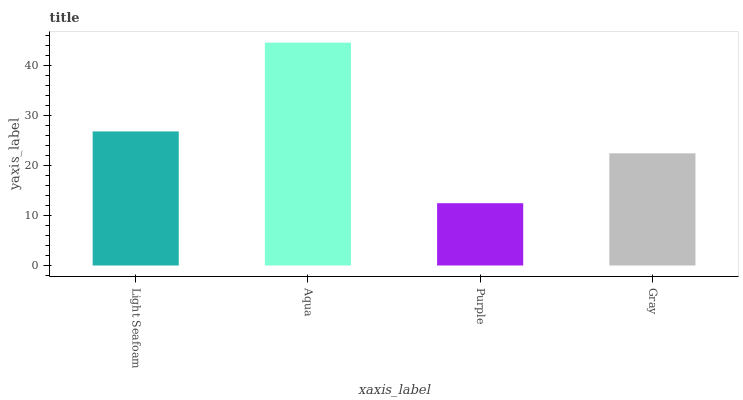Is Purple the minimum?
Answer yes or no. Yes. Is Aqua the maximum?
Answer yes or no. Yes. Is Aqua the minimum?
Answer yes or no. No. Is Purple the maximum?
Answer yes or no. No. Is Aqua greater than Purple?
Answer yes or no. Yes. Is Purple less than Aqua?
Answer yes or no. Yes. Is Purple greater than Aqua?
Answer yes or no. No. Is Aqua less than Purple?
Answer yes or no. No. Is Light Seafoam the high median?
Answer yes or no. Yes. Is Gray the low median?
Answer yes or no. Yes. Is Purple the high median?
Answer yes or no. No. Is Light Seafoam the low median?
Answer yes or no. No. 